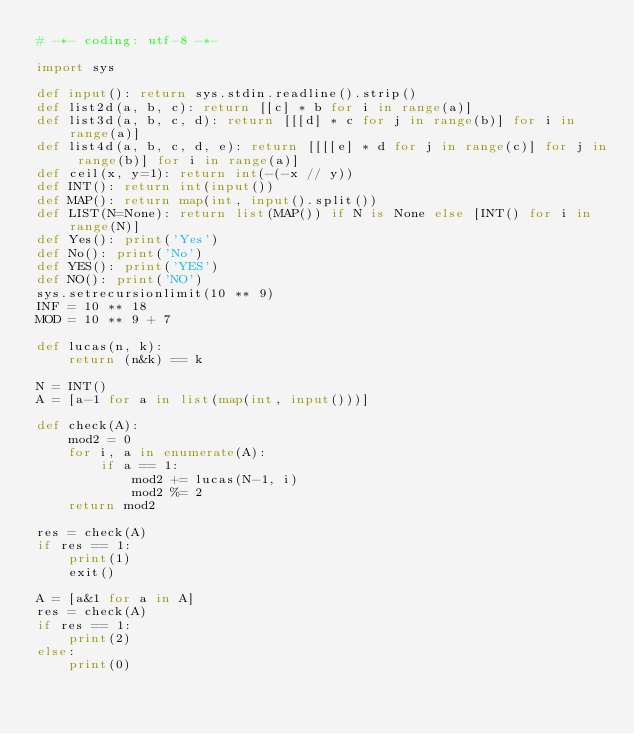<code> <loc_0><loc_0><loc_500><loc_500><_Python_># -*- coding: utf-8 -*-

import sys

def input(): return sys.stdin.readline().strip()
def list2d(a, b, c): return [[c] * b for i in range(a)]
def list3d(a, b, c, d): return [[[d] * c for j in range(b)] for i in range(a)]
def list4d(a, b, c, d, e): return [[[[e] * d for j in range(c)] for j in range(b)] for i in range(a)]
def ceil(x, y=1): return int(-(-x // y))
def INT(): return int(input())
def MAP(): return map(int, input().split())
def LIST(N=None): return list(MAP()) if N is None else [INT() for i in range(N)]
def Yes(): print('Yes')
def No(): print('No')
def YES(): print('YES')
def NO(): print('NO')
sys.setrecursionlimit(10 ** 9)
INF = 10 ** 18
MOD = 10 ** 9 + 7

def lucas(n, k):
    return (n&k) == k

N = INT()
A = [a-1 for a in list(map(int, input()))]

def check(A):
    mod2 = 0
    for i, a in enumerate(A):
        if a == 1:
            mod2 += lucas(N-1, i)
            mod2 %= 2
    return mod2

res = check(A)
if res == 1:
    print(1)
    exit()

A = [a&1 for a in A]
res = check(A)
if res == 1:
    print(2)
else:
    print(0)
</code> 